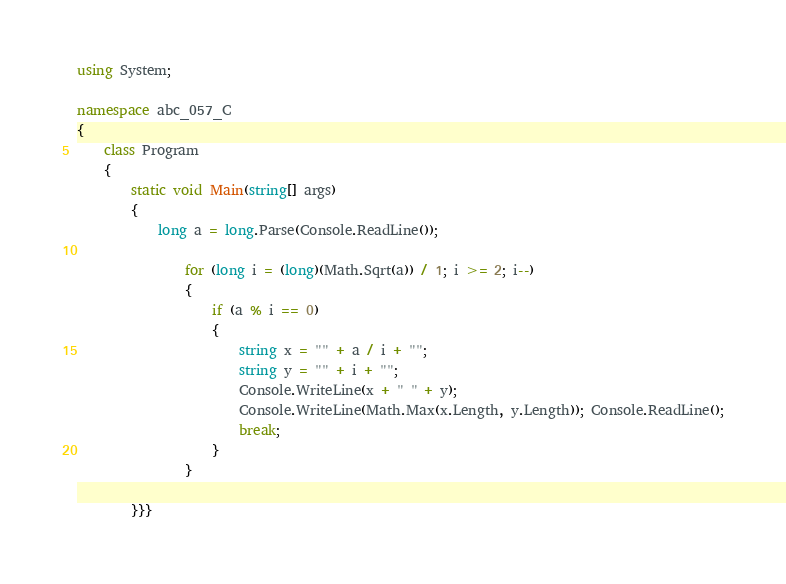Convert code to text. <code><loc_0><loc_0><loc_500><loc_500><_C#_>using System;

namespace abc_057_C
{
    class Program
    {
        static void Main(string[] args)
        {
            long a = long.Parse(Console.ReadLine());
         
                for (long i = (long)(Math.Sqrt(a)) / 1; i >= 2; i--)
                {
                    if (a % i == 0)
                    {
                        string x = "" + a / i + "";
                        string y = "" + i + "";
                        Console.WriteLine(x + " " + y);
                        Console.WriteLine(Math.Max(x.Length, y.Length)); Console.ReadLine();
                        break;
                    }
                }
            
        }}}</code> 